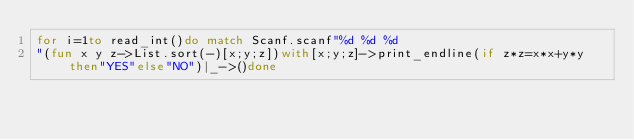<code> <loc_0><loc_0><loc_500><loc_500><_OCaml_>for i=1to read_int()do match Scanf.scanf"%d %d %d
"(fun x y z->List.sort(-)[x;y;z])with[x;y;z]->print_endline(if z*z=x*x+y*y then"YES"else"NO")|_->()done</code> 